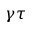<formula> <loc_0><loc_0><loc_500><loc_500>\gamma \tau</formula> 